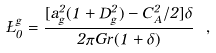<formula> <loc_0><loc_0><loc_500><loc_500>\Sigma _ { 0 } ^ { g } = \frac { [ a _ { g } ^ { 2 } ( 1 + D _ { g } ^ { 2 } ) - C _ { A } ^ { 2 } / 2 ] \delta } { 2 \pi G r ( 1 + \delta ) } \ ,</formula> 